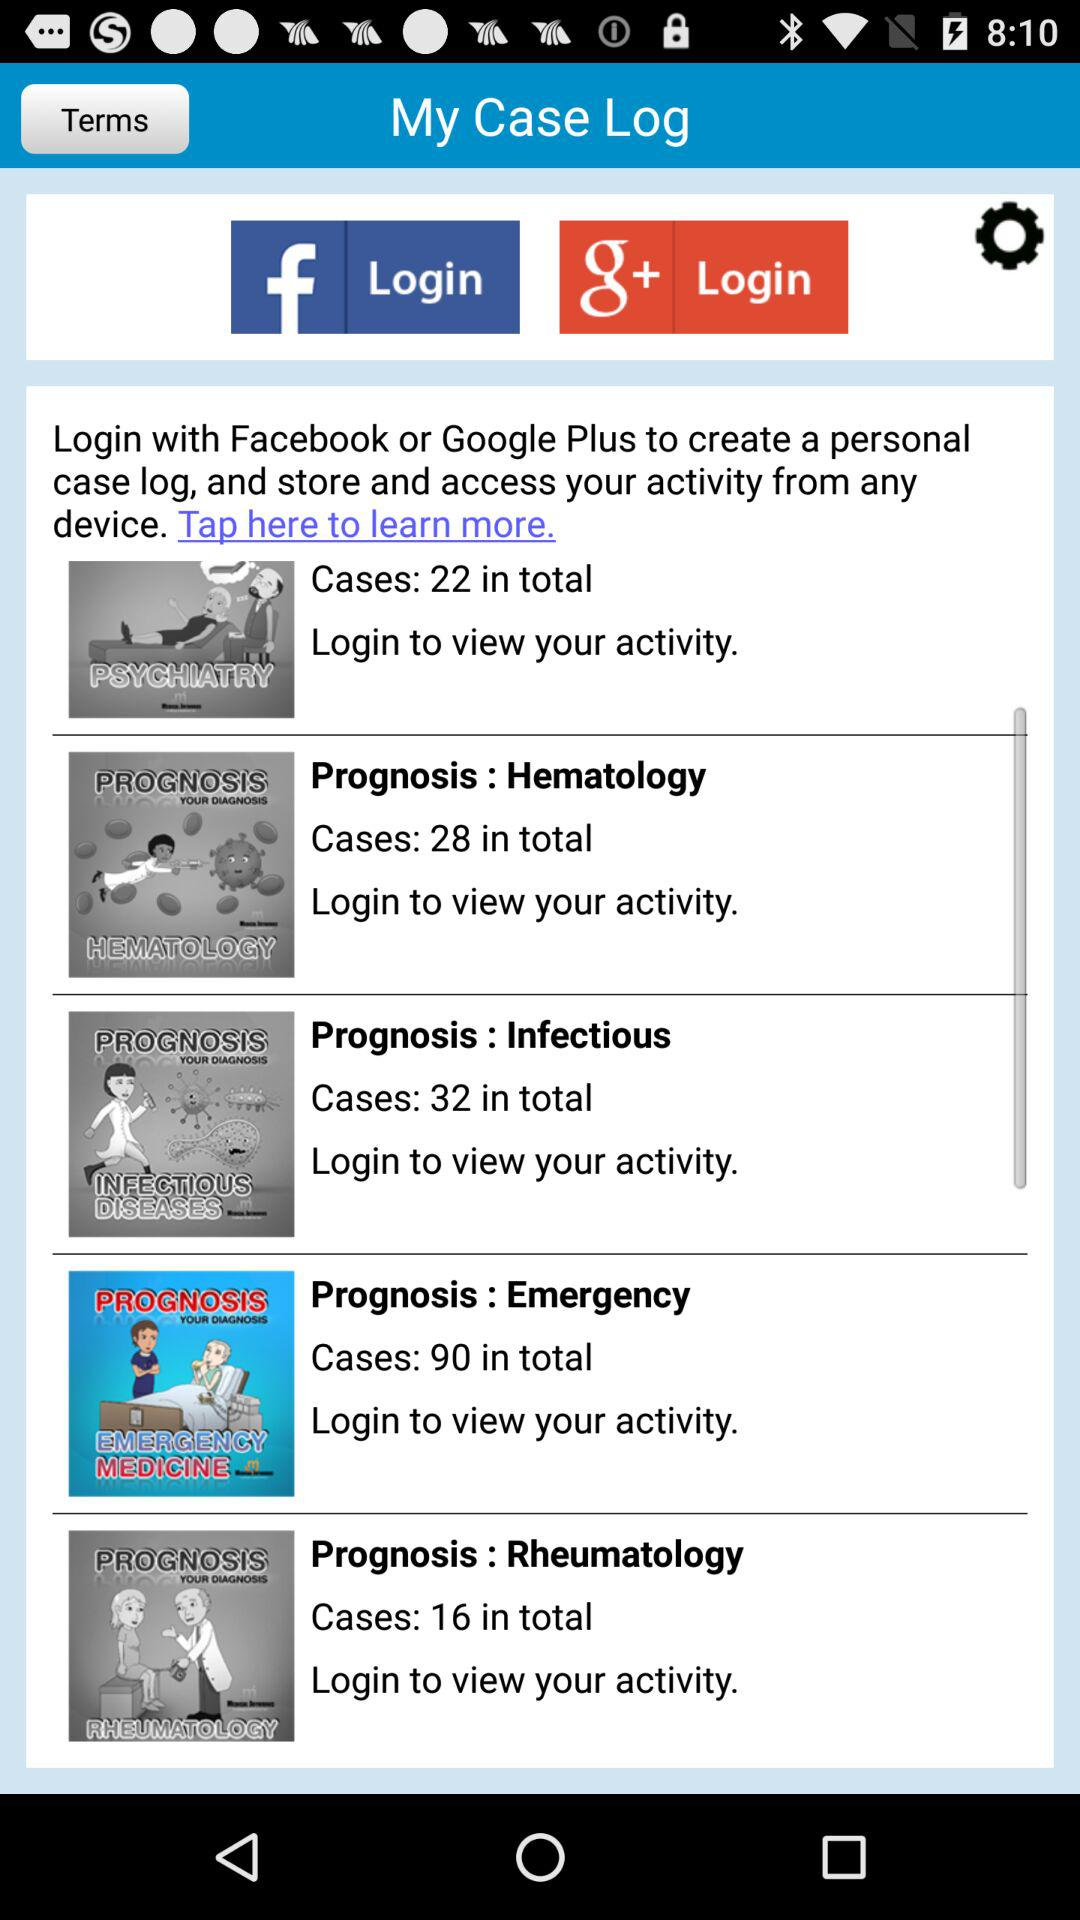How many cases are there in "Hematology"? There are 28 cases in "Hematology". 